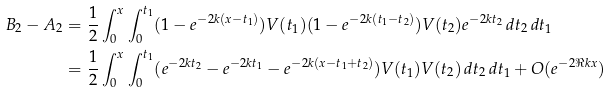<formula> <loc_0><loc_0><loc_500><loc_500>B _ { 2 } - A _ { 2 } & = \frac { 1 } { 2 } \int _ { 0 } ^ { x } \int _ { 0 } ^ { t _ { 1 } } ( 1 - e ^ { - 2 k ( x - t _ { 1 } ) } ) V ( t _ { 1 } ) ( 1 - e ^ { - 2 k ( t _ { 1 } - t _ { 2 } ) } ) V ( t _ { 2 } ) e ^ { - 2 k t _ { 2 } } \, d t _ { 2 } \, d t _ { 1 } \\ & = \frac { 1 } { 2 } \int _ { 0 } ^ { x } \int _ { 0 } ^ { t _ { 1 } } ( e ^ { - 2 k t _ { 2 } } - e ^ { - 2 k t _ { 1 } } - e ^ { - 2 k ( x - t _ { 1 } + t _ { 2 } ) } ) V ( t _ { 1 } ) V ( t _ { 2 } ) \, d t _ { 2 } \, d t _ { 1 } + O ( e ^ { - 2 \Re k x } )</formula> 